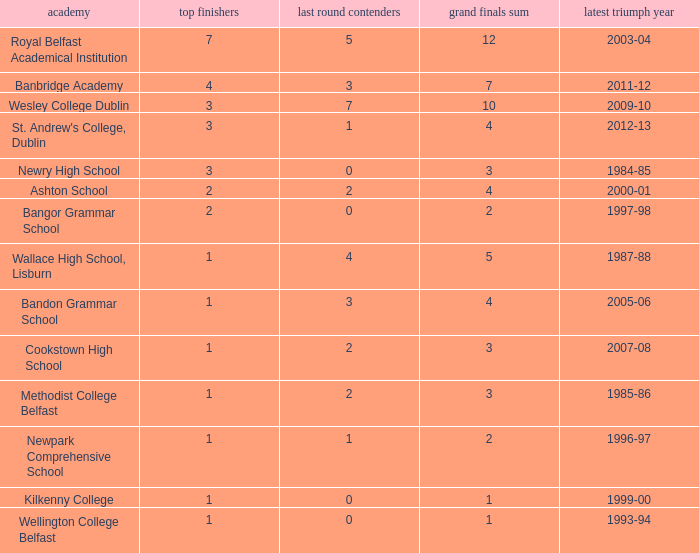What the name of  the school where the last win in 2007-08? Cookstown High School. 